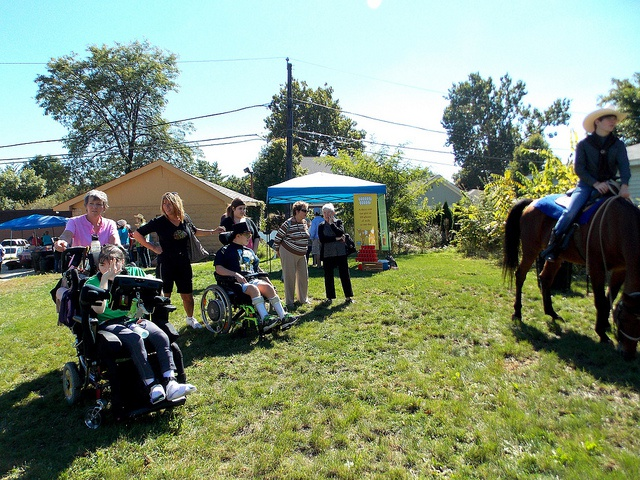Describe the objects in this image and their specific colors. I can see horse in lightblue, black, navy, white, and gray tones, people in lightblue, black, white, darkgray, and gray tones, people in lightblue, black, gray, navy, and tan tones, people in lightblue, black, maroon, and gray tones, and people in lightblue, black, gray, white, and darkgray tones in this image. 